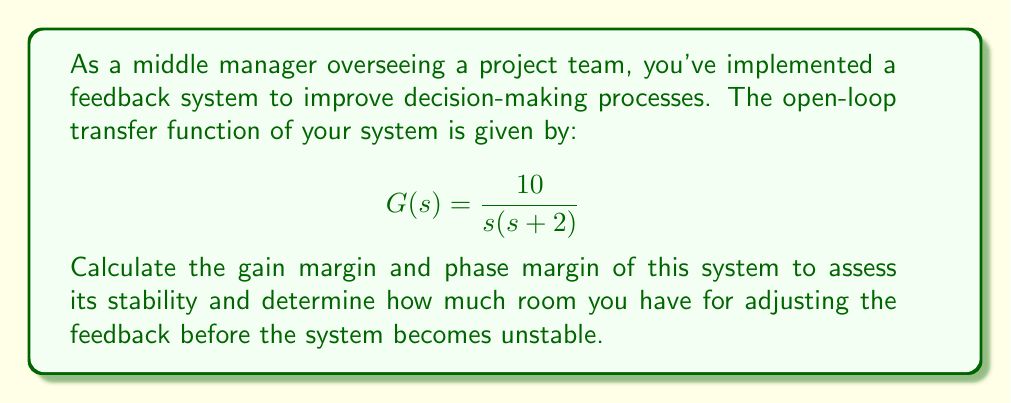Can you solve this math problem? To calculate the stability margins, we need to follow these steps:

1. Find the crossover frequencies:
   a. Gain crossover frequency (where |G(jω)| = 1)
   b. Phase crossover frequency (where ∠G(jω) = -180°)

2. Calculate the gain margin and phase margin

Step 1a: Gain crossover frequency
Let's find ω where |G(jω)| = 1

$$|G(jω)| = \left|\frac{10}{jω(jω+2)}\right| = \frac{10}{\sqrt{ω^2((ω^2+4)}} = 1$$

Solving this equation:
$$10^2 = ω^2(ω^2+4)$$
$$100 = ω^4+4ω^2$$
$$ω^4+4ω^2-100 = 0$$

This is a quadratic equation in ω^2. Solving it:
$$ω^2 = \frac{-4 \pm \sqrt{16+400}}{2} = \frac{-4 \pm \sqrt{416}}{2}$$
$$ω^2 = \frac{-4 \pm 20.4}{2}$$

We take the positive solution:
$$ω^2 = 8.2$$
$$ω = \sqrt{8.2} \approx 2.86 \text{ rad/s}$$

Step 1b: Phase crossover frequency
The phase of G(jω) is:
$$∠G(jω) = -90° - \tan^{-1}\left(\frac{ω}{2}\right)$$

We need to find ω where this equals -180°:
$$-90° - \tan^{-1}\left(\frac{ω}{2}\right) = -180°$$
$$\tan^{-1}\left(\frac{ω}{2}\right) = 90°$$
$$\frac{ω}{2} = \tan(90°)$$
$$ω = 2\tan(90°) = \infty$$

The phase never reaches -180°, so there is no finite phase crossover frequency.

Step 2: Calculate margins

Gain Margin:
Since there's no finite phase crossover frequency, the gain margin is infinite.

Phase Margin:
At the gain crossover frequency (ω = 2.86 rad/s):
$$∠G(j2.86) = -90° - \tan^{-1}\left(\frac{2.86}{2}\right)$$
$$= -90° - \tan^{-1}(1.43)$$
$$= -90° - 55.0°$$
$$= -145.0°$$

The phase margin is:
$$\text{PM} = 180° - |-145.0°| = 35.0°$$
Answer: Gain Margin: Infinite
Phase Margin: 35.0° 